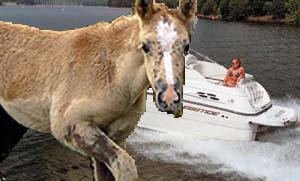What kind of activities are happening in the background of this image? In the background, there is a speedboat moving across what appears to be a lake. There's a person visible in the boat, likely enjoying a day of boating or possibly engaging in water sports such as water skiing. 